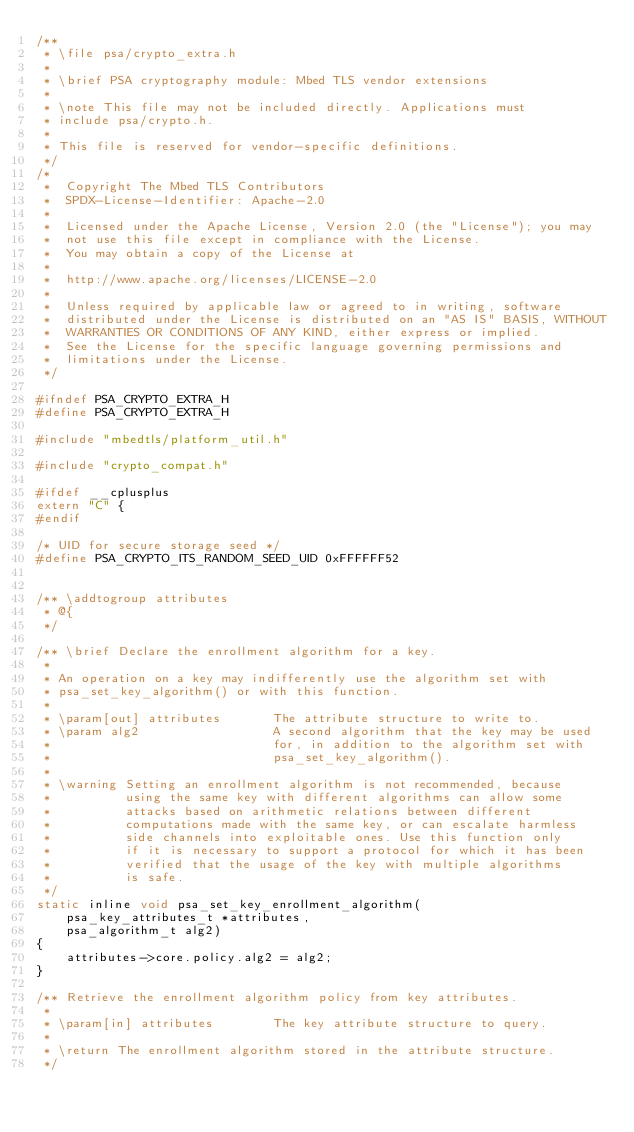Convert code to text. <code><loc_0><loc_0><loc_500><loc_500><_C_>/**
 * \file psa/crypto_extra.h
 *
 * \brief PSA cryptography module: Mbed TLS vendor extensions
 *
 * \note This file may not be included directly. Applications must
 * include psa/crypto.h.
 *
 * This file is reserved for vendor-specific definitions.
 */
/*
 *  Copyright The Mbed TLS Contributors
 *  SPDX-License-Identifier: Apache-2.0
 *
 *  Licensed under the Apache License, Version 2.0 (the "License"); you may
 *  not use this file except in compliance with the License.
 *  You may obtain a copy of the License at
 *
 *  http://www.apache.org/licenses/LICENSE-2.0
 *
 *  Unless required by applicable law or agreed to in writing, software
 *  distributed under the License is distributed on an "AS IS" BASIS, WITHOUT
 *  WARRANTIES OR CONDITIONS OF ANY KIND, either express or implied.
 *  See the License for the specific language governing permissions and
 *  limitations under the License.
 */

#ifndef PSA_CRYPTO_EXTRA_H
#define PSA_CRYPTO_EXTRA_H

#include "mbedtls/platform_util.h"

#include "crypto_compat.h"

#ifdef __cplusplus
extern "C" {
#endif

/* UID for secure storage seed */
#define PSA_CRYPTO_ITS_RANDOM_SEED_UID 0xFFFFFF52


/** \addtogroup attributes
 * @{
 */

/** \brief Declare the enrollment algorithm for a key.
 *
 * An operation on a key may indifferently use the algorithm set with
 * psa_set_key_algorithm() or with this function.
 *
 * \param[out] attributes       The attribute structure to write to.
 * \param alg2                  A second algorithm that the key may be used
 *                              for, in addition to the algorithm set with
 *                              psa_set_key_algorithm().
 *
 * \warning Setting an enrollment algorithm is not recommended, because
 *          using the same key with different algorithms can allow some
 *          attacks based on arithmetic relations between different
 *          computations made with the same key, or can escalate harmless
 *          side channels into exploitable ones. Use this function only
 *          if it is necessary to support a protocol for which it has been
 *          verified that the usage of the key with multiple algorithms
 *          is safe.
 */
static inline void psa_set_key_enrollment_algorithm(
    psa_key_attributes_t *attributes,
    psa_algorithm_t alg2)
{
    attributes->core.policy.alg2 = alg2;
}

/** Retrieve the enrollment algorithm policy from key attributes.
 *
 * \param[in] attributes        The key attribute structure to query.
 *
 * \return The enrollment algorithm stored in the attribute structure.
 */</code> 